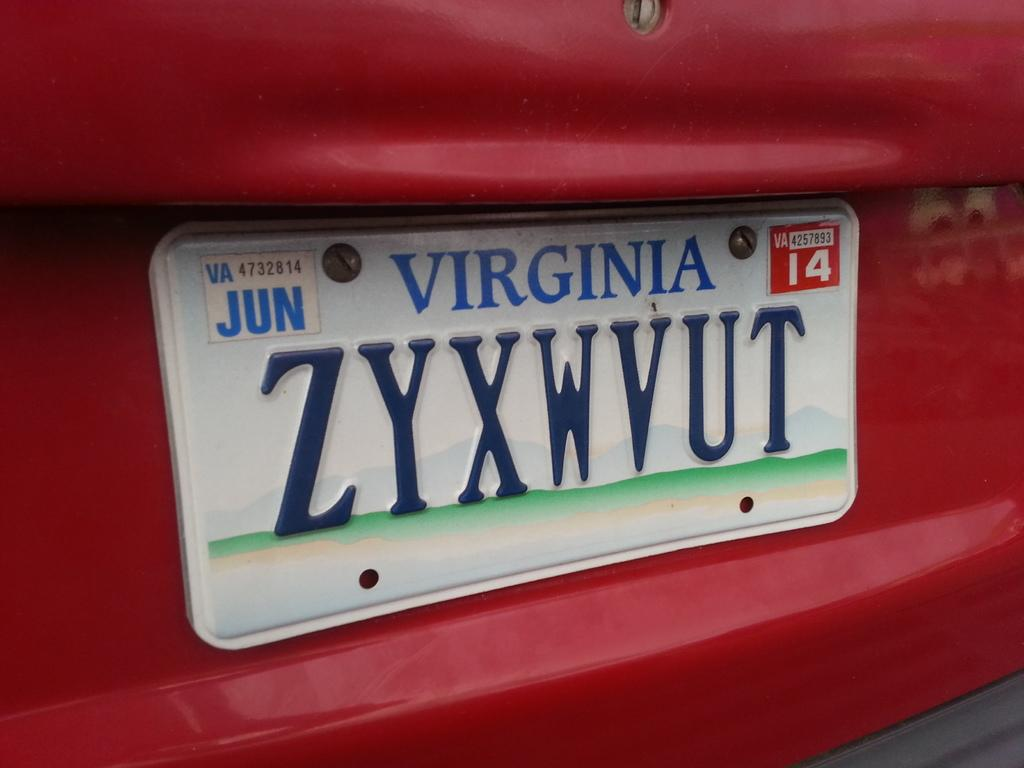<image>
Present a compact description of the photo's key features. A Virginia license plate expired June 2014, license plate ZYXWVUT. 